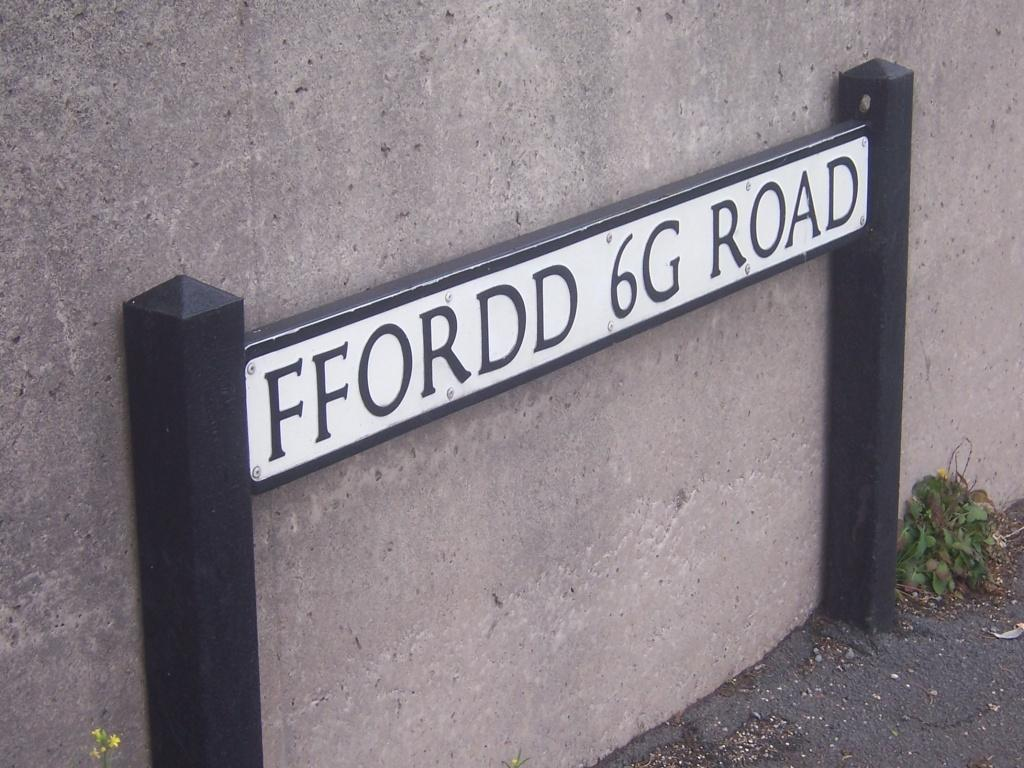What is on the wall in the image? There is a board on the wall in the image. What can be seen on the right side of the image? There is a plant on the right side of the image. Where can you find a pair of jeans in the image? There are no jeans present in the image. What type of plantation is visible in the image? There is no plantation present in the image; it only features a board on the wall and a plant on the right side. 